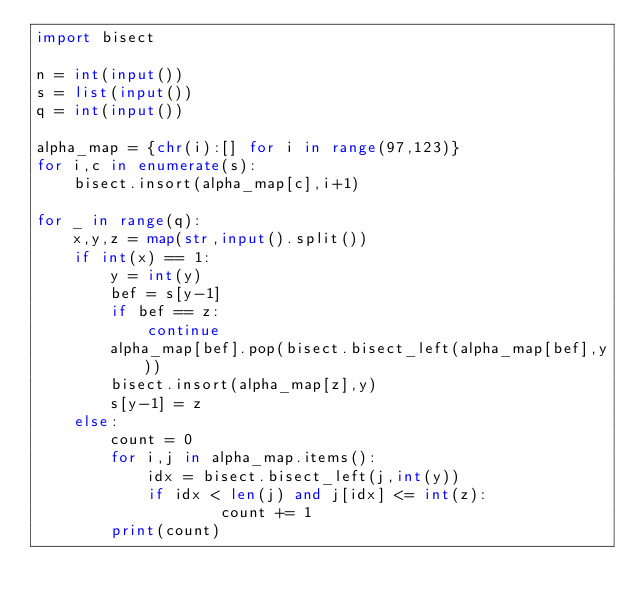<code> <loc_0><loc_0><loc_500><loc_500><_Python_>import bisect

n = int(input())
s = list(input())
q = int(input())

alpha_map = {chr(i):[] for i in range(97,123)}
for i,c in enumerate(s):
    bisect.insort(alpha_map[c],i+1)
    
for _ in range(q):
    x,y,z = map(str,input().split())
    if int(x) == 1:
        y = int(y)
        bef = s[y-1]
        if bef == z:
            continue
        alpha_map[bef].pop(bisect.bisect_left(alpha_map[bef],y))
        bisect.insort(alpha_map[z],y)
        s[y-1] = z
    else:
        count = 0
        for i,j in alpha_map.items():
            idx = bisect.bisect_left(j,int(y))
            if idx < len(j) and j[idx] <= int(z):
                    count += 1
        print(count)</code> 